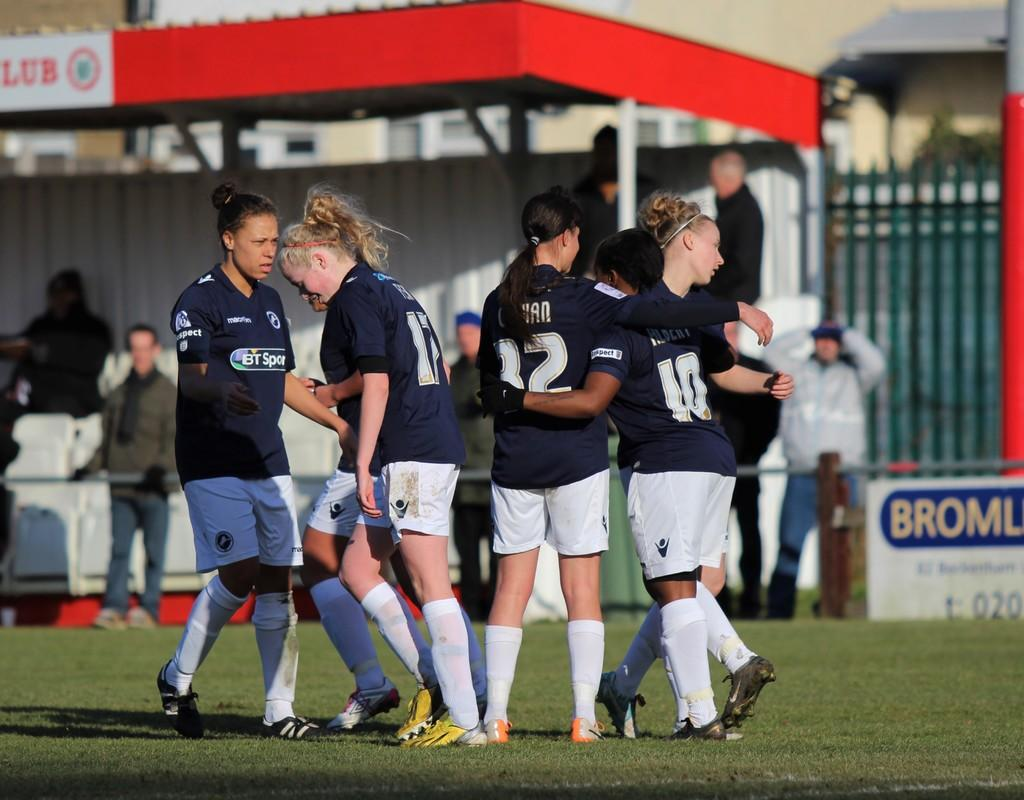<image>
Relay a brief, clear account of the picture shown. several women are huddled together with matching sports uniforms with one having the number 12 on her back. 